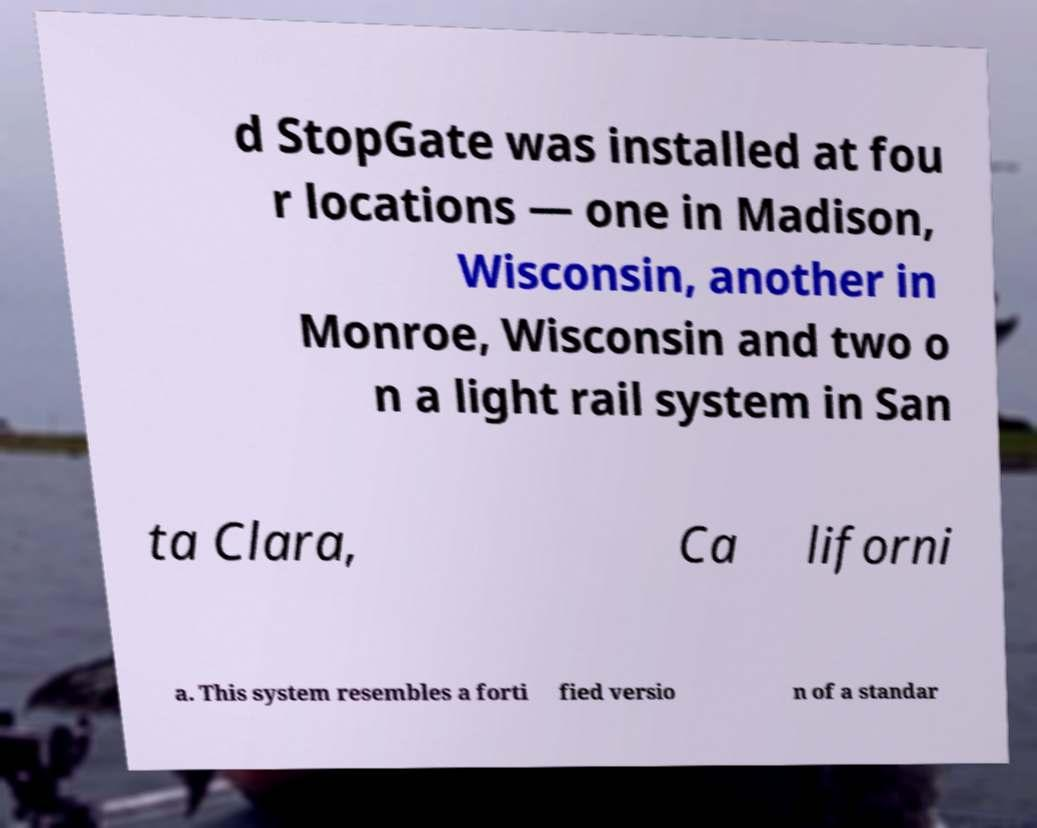For documentation purposes, I need the text within this image transcribed. Could you provide that? d StopGate was installed at fou r locations — one in Madison, Wisconsin, another in Monroe, Wisconsin and two o n a light rail system in San ta Clara, Ca liforni a. This system resembles a forti fied versio n of a standar 